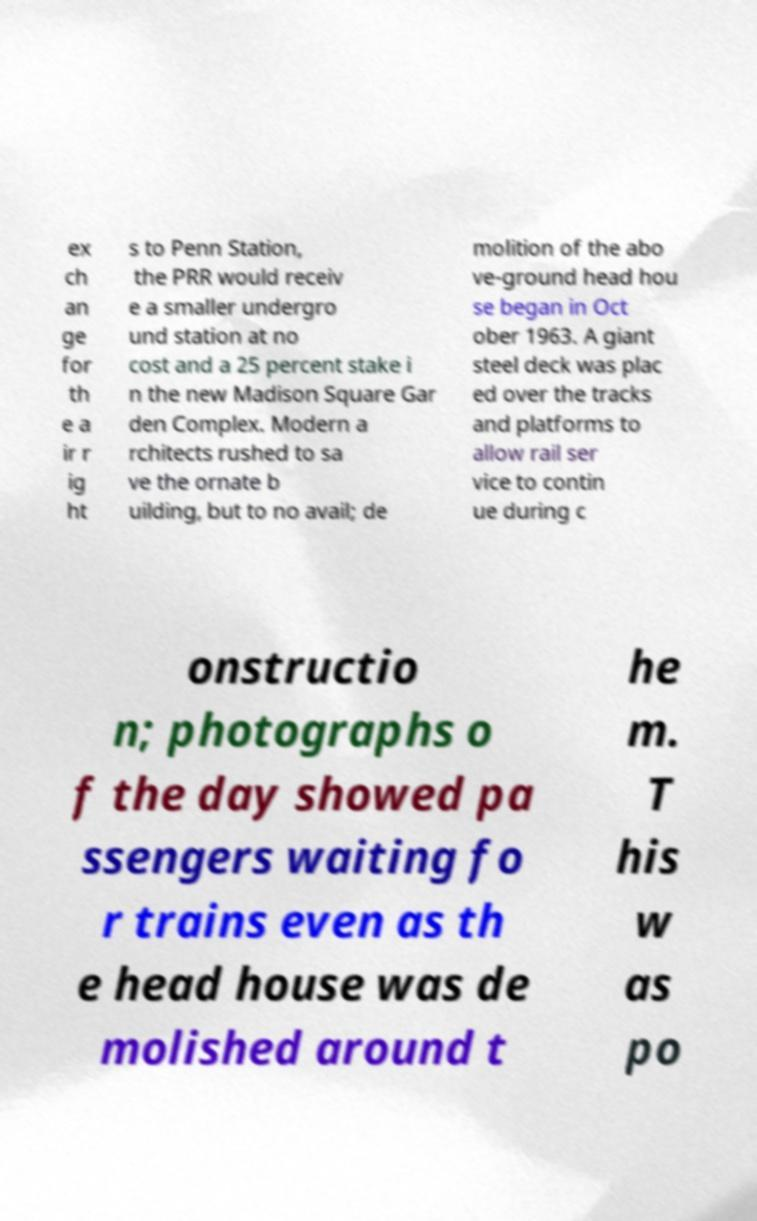For documentation purposes, I need the text within this image transcribed. Could you provide that? ex ch an ge for th e a ir r ig ht s to Penn Station, the PRR would receiv e a smaller undergro und station at no cost and a 25 percent stake i n the new Madison Square Gar den Complex. Modern a rchitects rushed to sa ve the ornate b uilding, but to no avail; de molition of the abo ve-ground head hou se began in Oct ober 1963. A giant steel deck was plac ed over the tracks and platforms to allow rail ser vice to contin ue during c onstructio n; photographs o f the day showed pa ssengers waiting fo r trains even as th e head house was de molished around t he m. T his w as po 